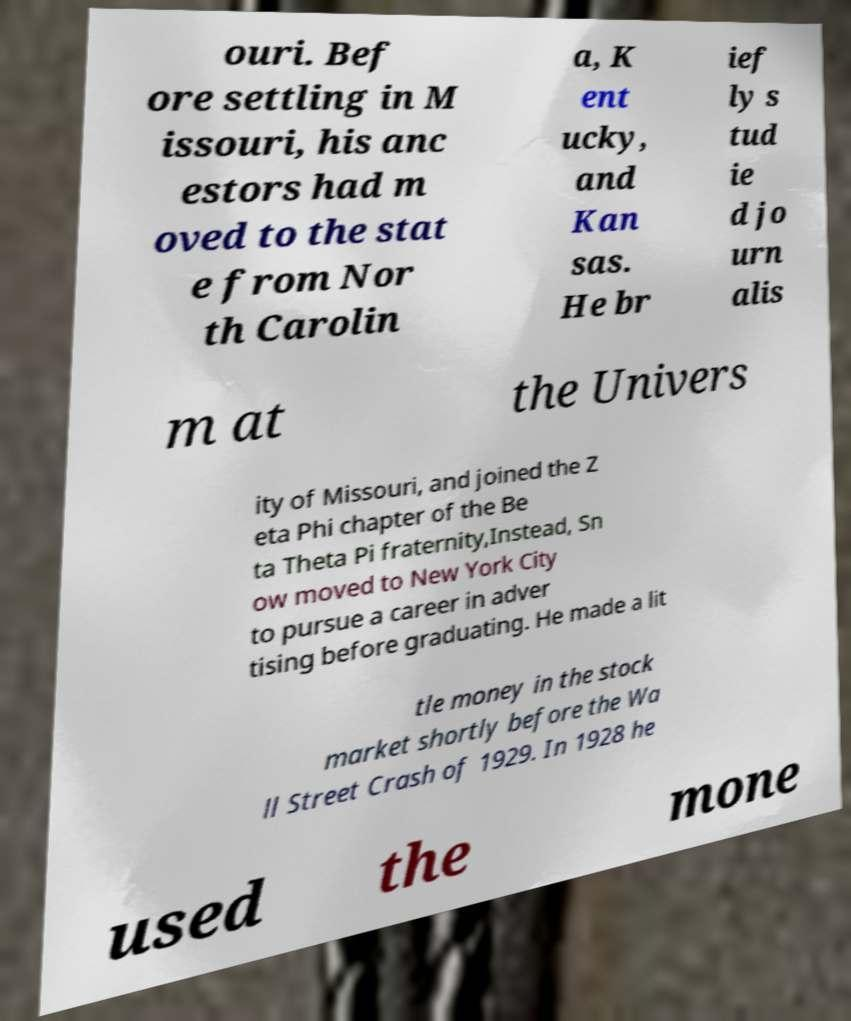Please identify and transcribe the text found in this image. ouri. Bef ore settling in M issouri, his anc estors had m oved to the stat e from Nor th Carolin a, K ent ucky, and Kan sas. He br ief ly s tud ie d jo urn alis m at the Univers ity of Missouri, and joined the Z eta Phi chapter of the Be ta Theta Pi fraternity,Instead, Sn ow moved to New York City to pursue a career in adver tising before graduating. He made a lit tle money in the stock market shortly before the Wa ll Street Crash of 1929. In 1928 he used the mone 